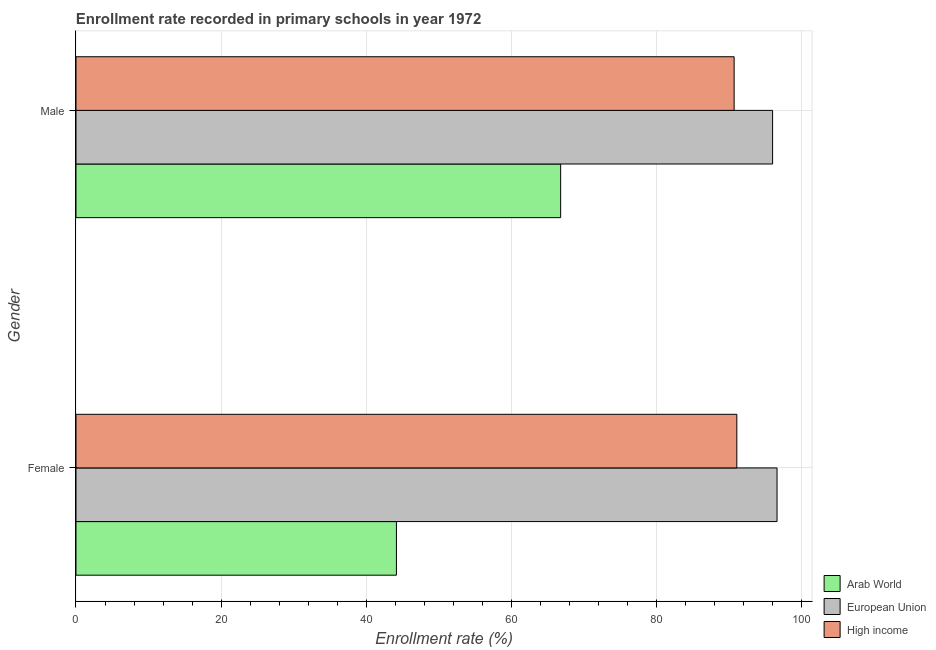Are the number of bars per tick equal to the number of legend labels?
Give a very brief answer. Yes. How many bars are there on the 1st tick from the top?
Ensure brevity in your answer.  3. What is the enrollment rate of female students in European Union?
Offer a terse response. 96.62. Across all countries, what is the maximum enrollment rate of male students?
Make the answer very short. 96.01. Across all countries, what is the minimum enrollment rate of female students?
Provide a succinct answer. 44.16. In which country was the enrollment rate of female students minimum?
Ensure brevity in your answer.  Arab World. What is the total enrollment rate of female students in the graph?
Offer a very short reply. 231.86. What is the difference between the enrollment rate of female students in High income and that in Arab World?
Ensure brevity in your answer.  46.91. What is the difference between the enrollment rate of male students in European Union and the enrollment rate of female students in Arab World?
Ensure brevity in your answer.  51.84. What is the average enrollment rate of male students per country?
Ensure brevity in your answer.  84.5. What is the difference between the enrollment rate of male students and enrollment rate of female students in European Union?
Your answer should be compact. -0.61. In how many countries, is the enrollment rate of female students greater than 88 %?
Ensure brevity in your answer.  2. What is the ratio of the enrollment rate of female students in High income to that in Arab World?
Give a very brief answer. 2.06. Is the enrollment rate of female students in Arab World less than that in European Union?
Provide a succinct answer. Yes. How many countries are there in the graph?
Provide a succinct answer. 3. Does the graph contain any zero values?
Offer a terse response. No. Where does the legend appear in the graph?
Keep it short and to the point. Bottom right. How many legend labels are there?
Offer a very short reply. 3. What is the title of the graph?
Your response must be concise. Enrollment rate recorded in primary schools in year 1972. What is the label or title of the X-axis?
Provide a short and direct response. Enrollment rate (%). What is the label or title of the Y-axis?
Provide a short and direct response. Gender. What is the Enrollment rate (%) of Arab World in Female?
Offer a very short reply. 44.16. What is the Enrollment rate (%) in European Union in Female?
Make the answer very short. 96.62. What is the Enrollment rate (%) in High income in Female?
Your response must be concise. 91.08. What is the Enrollment rate (%) in Arab World in Male?
Provide a succinct answer. 66.8. What is the Enrollment rate (%) in European Union in Male?
Your answer should be compact. 96.01. What is the Enrollment rate (%) in High income in Male?
Provide a short and direct response. 90.71. Across all Gender, what is the maximum Enrollment rate (%) in Arab World?
Give a very brief answer. 66.8. Across all Gender, what is the maximum Enrollment rate (%) of European Union?
Provide a succinct answer. 96.62. Across all Gender, what is the maximum Enrollment rate (%) of High income?
Make the answer very short. 91.08. Across all Gender, what is the minimum Enrollment rate (%) of Arab World?
Offer a terse response. 44.16. Across all Gender, what is the minimum Enrollment rate (%) in European Union?
Your response must be concise. 96.01. Across all Gender, what is the minimum Enrollment rate (%) of High income?
Give a very brief answer. 90.71. What is the total Enrollment rate (%) in Arab World in the graph?
Offer a terse response. 110.96. What is the total Enrollment rate (%) of European Union in the graph?
Make the answer very short. 192.63. What is the total Enrollment rate (%) in High income in the graph?
Your response must be concise. 181.78. What is the difference between the Enrollment rate (%) of Arab World in Female and that in Male?
Your answer should be very brief. -22.63. What is the difference between the Enrollment rate (%) in European Union in Female and that in Male?
Keep it short and to the point. 0.61. What is the difference between the Enrollment rate (%) in High income in Female and that in Male?
Offer a very short reply. 0.37. What is the difference between the Enrollment rate (%) of Arab World in Female and the Enrollment rate (%) of European Union in Male?
Offer a very short reply. -51.84. What is the difference between the Enrollment rate (%) of Arab World in Female and the Enrollment rate (%) of High income in Male?
Your answer should be compact. -46.54. What is the difference between the Enrollment rate (%) in European Union in Female and the Enrollment rate (%) in High income in Male?
Provide a short and direct response. 5.91. What is the average Enrollment rate (%) of Arab World per Gender?
Ensure brevity in your answer.  55.48. What is the average Enrollment rate (%) in European Union per Gender?
Your answer should be very brief. 96.31. What is the average Enrollment rate (%) in High income per Gender?
Offer a very short reply. 90.89. What is the difference between the Enrollment rate (%) in Arab World and Enrollment rate (%) in European Union in Female?
Make the answer very short. -52.46. What is the difference between the Enrollment rate (%) in Arab World and Enrollment rate (%) in High income in Female?
Ensure brevity in your answer.  -46.91. What is the difference between the Enrollment rate (%) in European Union and Enrollment rate (%) in High income in Female?
Keep it short and to the point. 5.54. What is the difference between the Enrollment rate (%) of Arab World and Enrollment rate (%) of European Union in Male?
Your answer should be very brief. -29.21. What is the difference between the Enrollment rate (%) in Arab World and Enrollment rate (%) in High income in Male?
Keep it short and to the point. -23.91. What is the difference between the Enrollment rate (%) in European Union and Enrollment rate (%) in High income in Male?
Give a very brief answer. 5.3. What is the ratio of the Enrollment rate (%) in Arab World in Female to that in Male?
Keep it short and to the point. 0.66. What is the ratio of the Enrollment rate (%) in European Union in Female to that in Male?
Your response must be concise. 1.01. What is the ratio of the Enrollment rate (%) of High income in Female to that in Male?
Provide a short and direct response. 1. What is the difference between the highest and the second highest Enrollment rate (%) in Arab World?
Keep it short and to the point. 22.63. What is the difference between the highest and the second highest Enrollment rate (%) of European Union?
Provide a succinct answer. 0.61. What is the difference between the highest and the second highest Enrollment rate (%) of High income?
Ensure brevity in your answer.  0.37. What is the difference between the highest and the lowest Enrollment rate (%) in Arab World?
Give a very brief answer. 22.63. What is the difference between the highest and the lowest Enrollment rate (%) in European Union?
Ensure brevity in your answer.  0.61. What is the difference between the highest and the lowest Enrollment rate (%) in High income?
Your response must be concise. 0.37. 